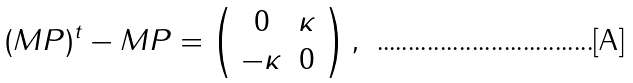Convert formula to latex. <formula><loc_0><loc_0><loc_500><loc_500>( M P ) ^ { t } - M P = \left ( \begin{array} { c c } 0 & \kappa \\ - \kappa & 0 \end{array} \right ) ,</formula> 